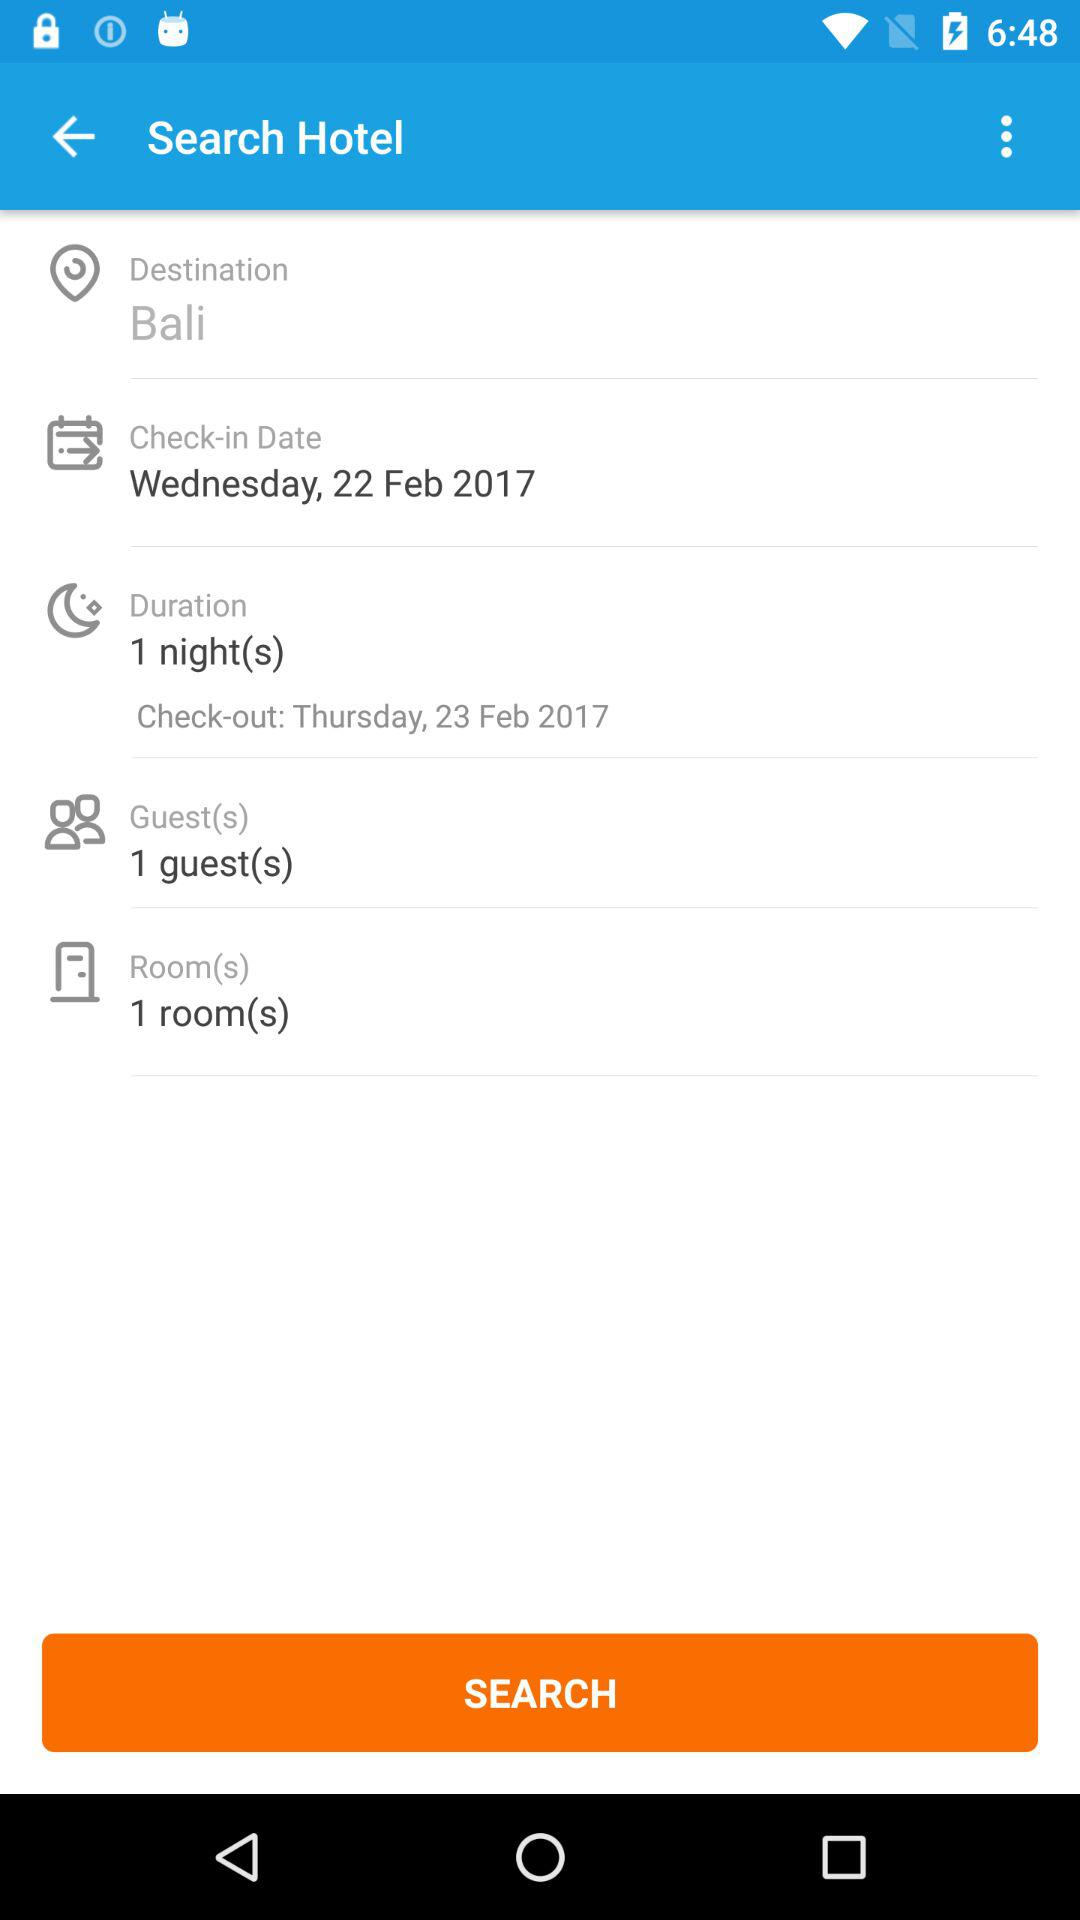For which date is check-out scheduled? The check-out is scheduled for Thursday, February 23, 2017. 